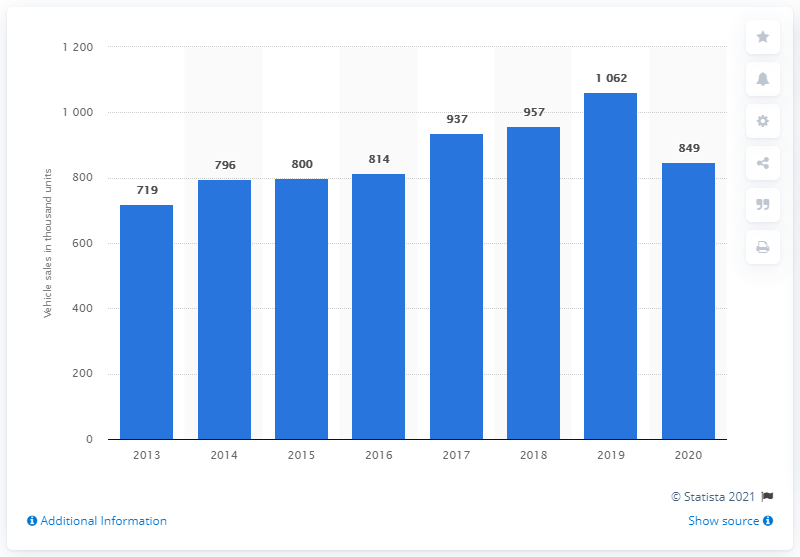List a handful of essential elements in this visual. Skoda's worldwide vehicle sales came to an end in the year 2020. Skoda first reported its worldwide vehicle sales in 2013. 